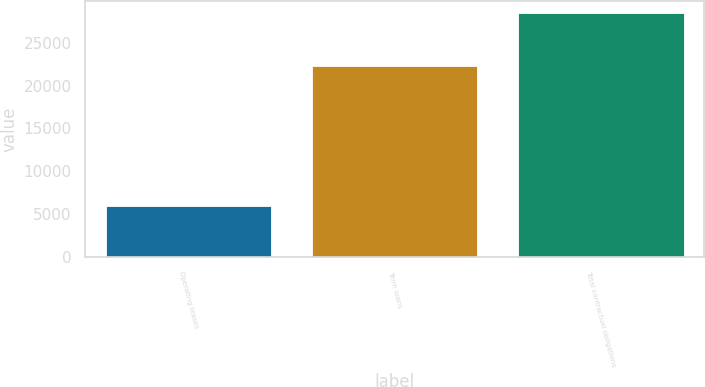Convert chart. <chart><loc_0><loc_0><loc_500><loc_500><bar_chart><fcel>Operating leases<fcel>Term loans<fcel>Total contractual obligations<nl><fcel>5979<fcel>22250<fcel>28406<nl></chart> 